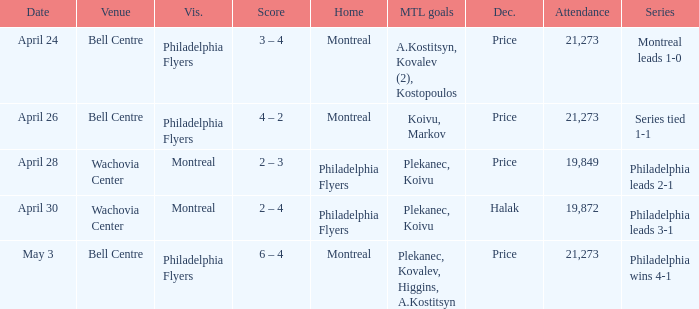What was the average attendance when the decision was price and montreal were the visitors? 19849.0. 